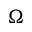<formula> <loc_0><loc_0><loc_500><loc_500>\Omega</formula> 